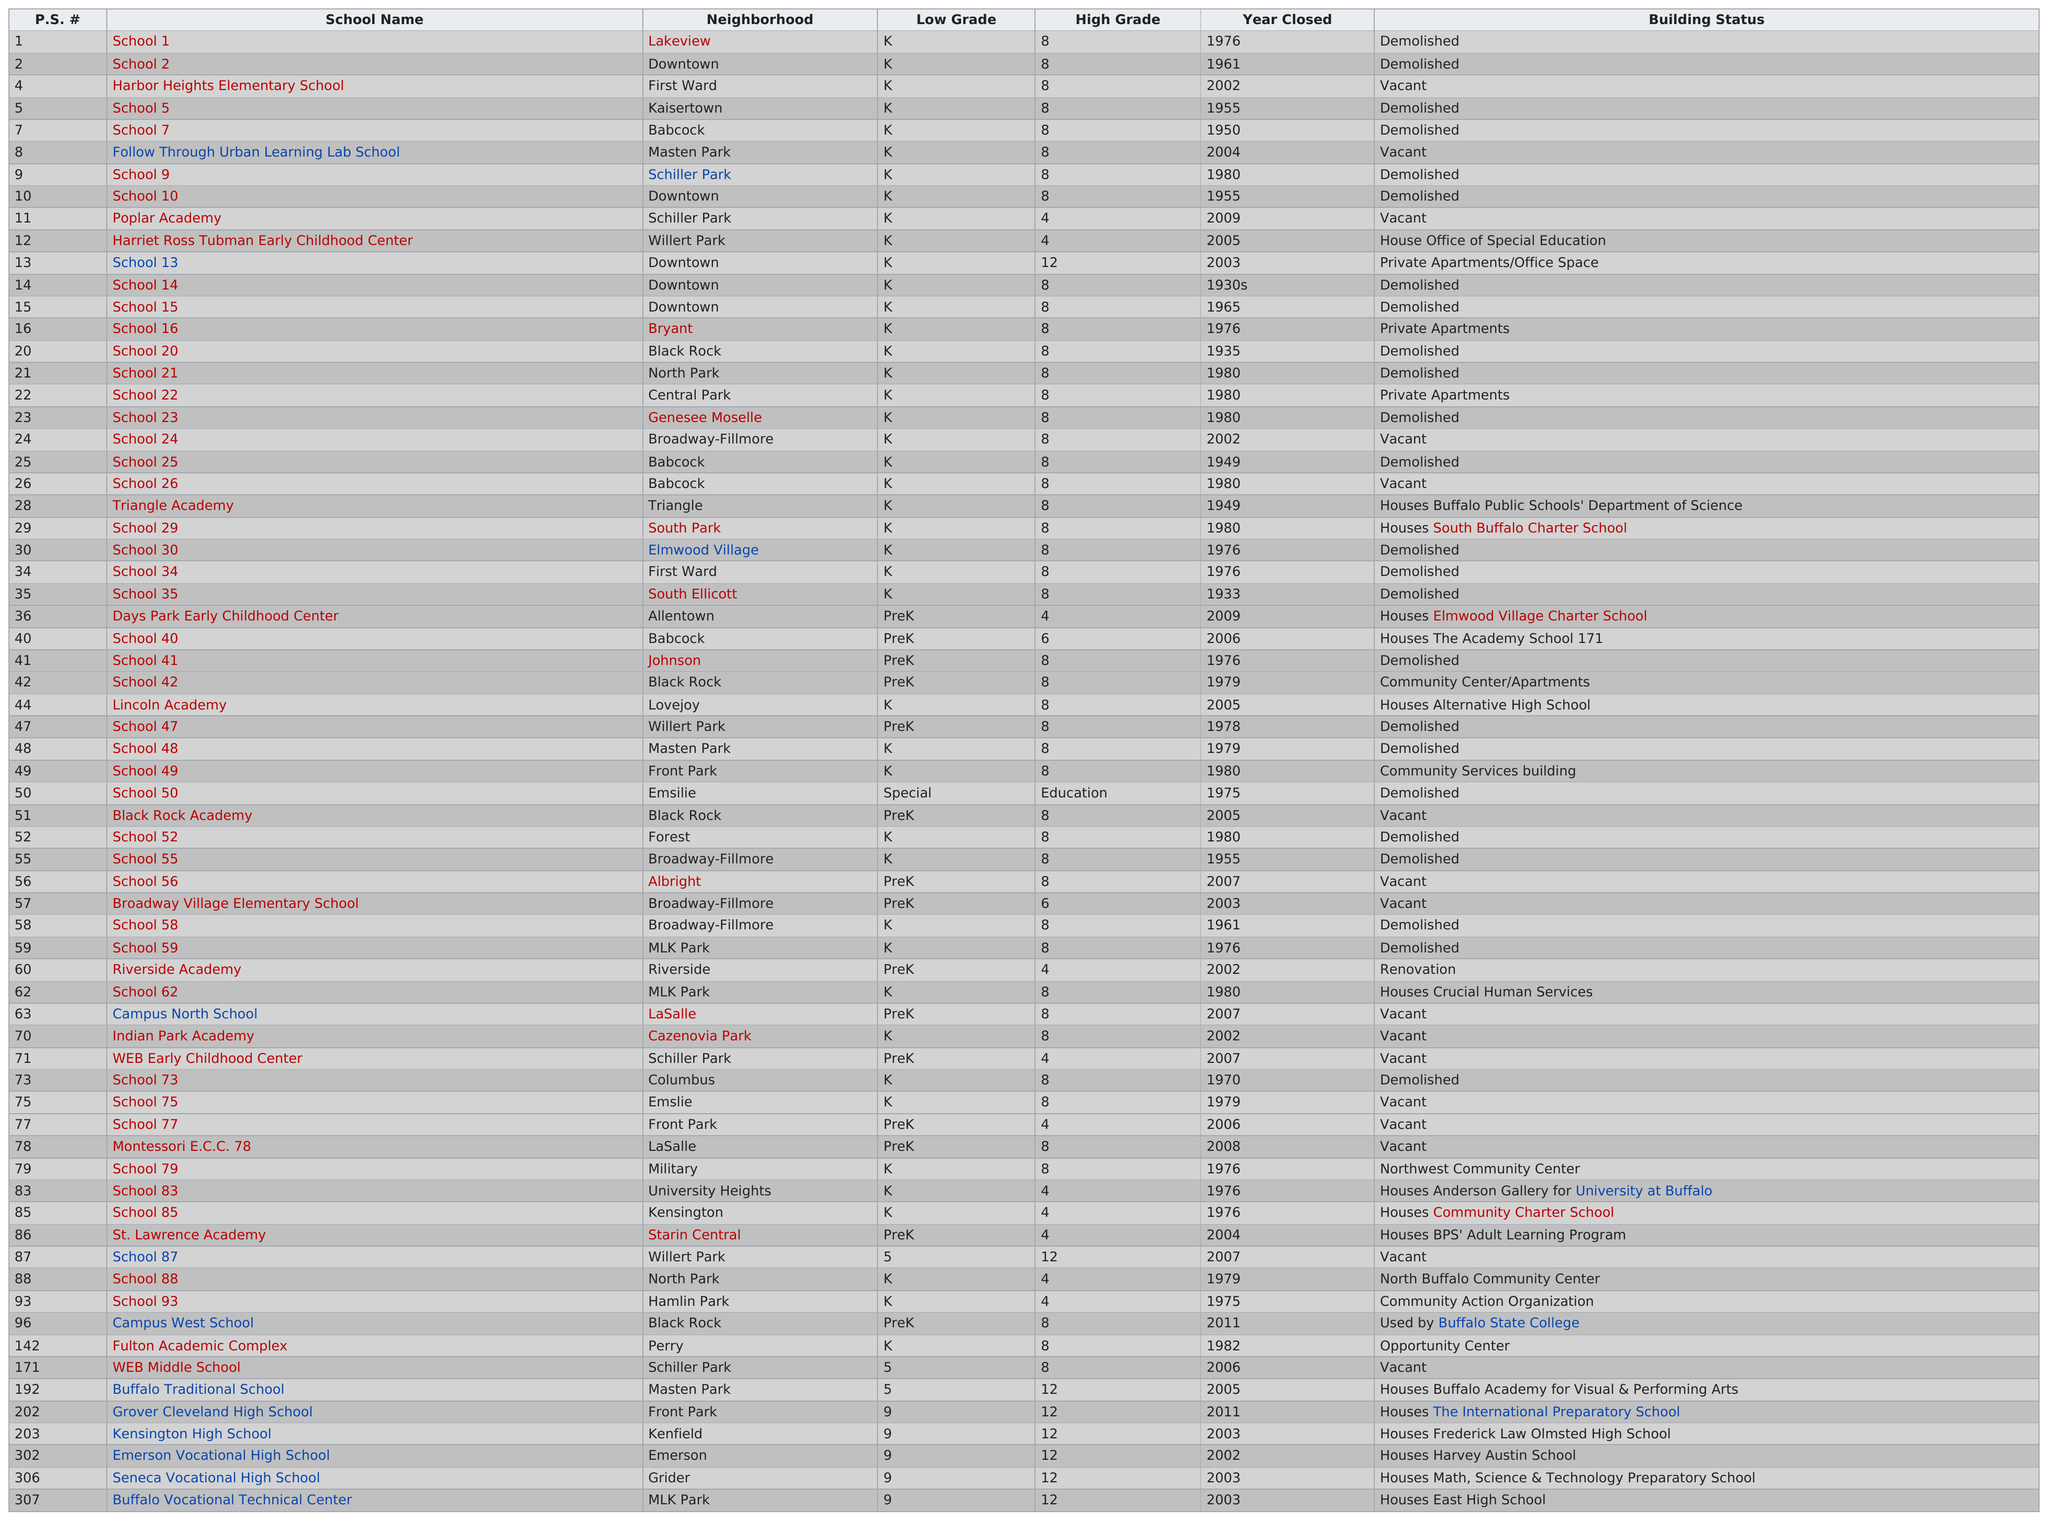Mention a couple of crucial points in this snapshot. The first school to have been closed was School 35. I have determined that School 73, a school located in the Columbus neighborhood that was demolished, was a school that was part of the Chicago Public Schools system. Three schools were converted into private apartments. The total number of schools that were demolished is 24. The total number of schools that are now vacant is 16. 